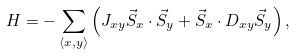Convert formula to latex. <formula><loc_0><loc_0><loc_500><loc_500>H = - \sum _ { \langle x , y \rangle } \left ( J _ { x y } \vec { S } _ { x } \cdot \vec { S } _ { y } + \vec { S } _ { x } \cdot D _ { x y } \vec { S } _ { y } \right ) ,</formula> 